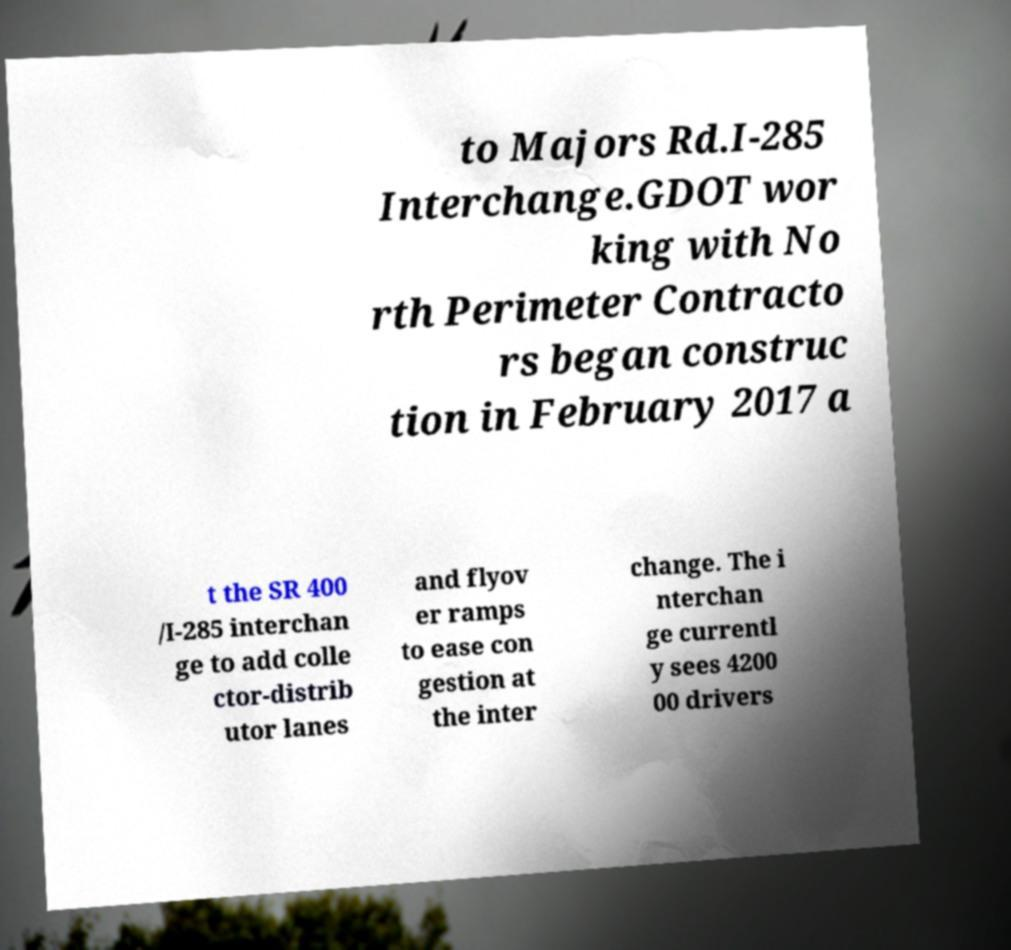Please identify and transcribe the text found in this image. to Majors Rd.I-285 Interchange.GDOT wor king with No rth Perimeter Contracto rs began construc tion in February 2017 a t the SR 400 /I-285 interchan ge to add colle ctor-distrib utor lanes and flyov er ramps to ease con gestion at the inter change. The i nterchan ge currentl y sees 4200 00 drivers 